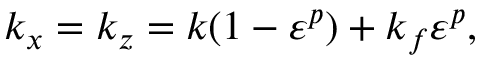<formula> <loc_0><loc_0><loc_500><loc_500>k _ { x } = k _ { z } = k ( 1 - \varepsilon ^ { p } ) + k _ { f } \varepsilon ^ { p } ,</formula> 